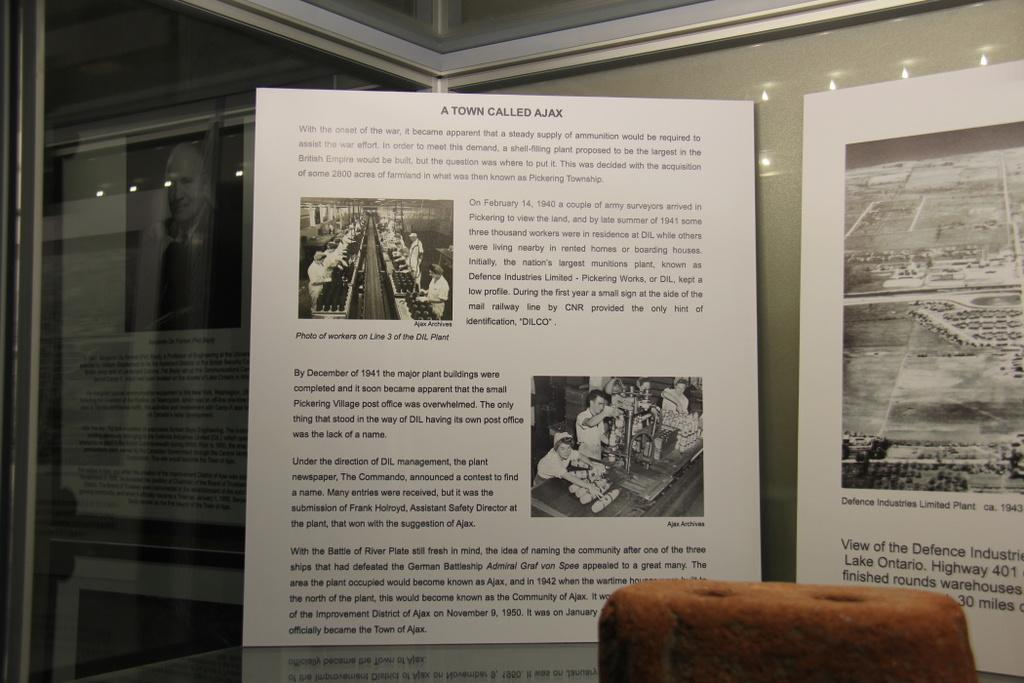What type of furniture is present in the image? There is a table in the image. What is located behind the table? There is a wall in the image. What is on the wall? There are posters on the wall. What can be seen in the images on the posters? The posters have images of people. What is written on the posters? There is writing on the posters. What type of texture can be seen on the floor in the image? There is no information about the floor in the image, so we cannot determine the texture. Is there a train visible in the image? No, there is no train present in the image. 